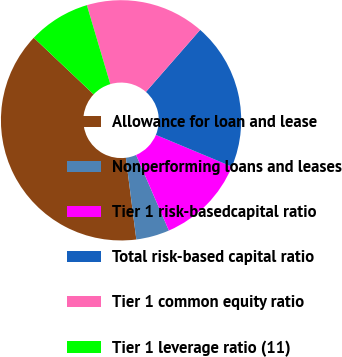Convert chart. <chart><loc_0><loc_0><loc_500><loc_500><pie_chart><fcel>Allowance for loan and lease<fcel>Nonperforming loans and leases<fcel>Tier 1 risk-basedcapital ratio<fcel>Total risk-based capital ratio<fcel>Tier 1 common equity ratio<fcel>Tier 1 leverage ratio (11)<nl><fcel>39.09%<fcel>4.49%<fcel>12.18%<fcel>19.87%<fcel>16.03%<fcel>8.34%<nl></chart> 